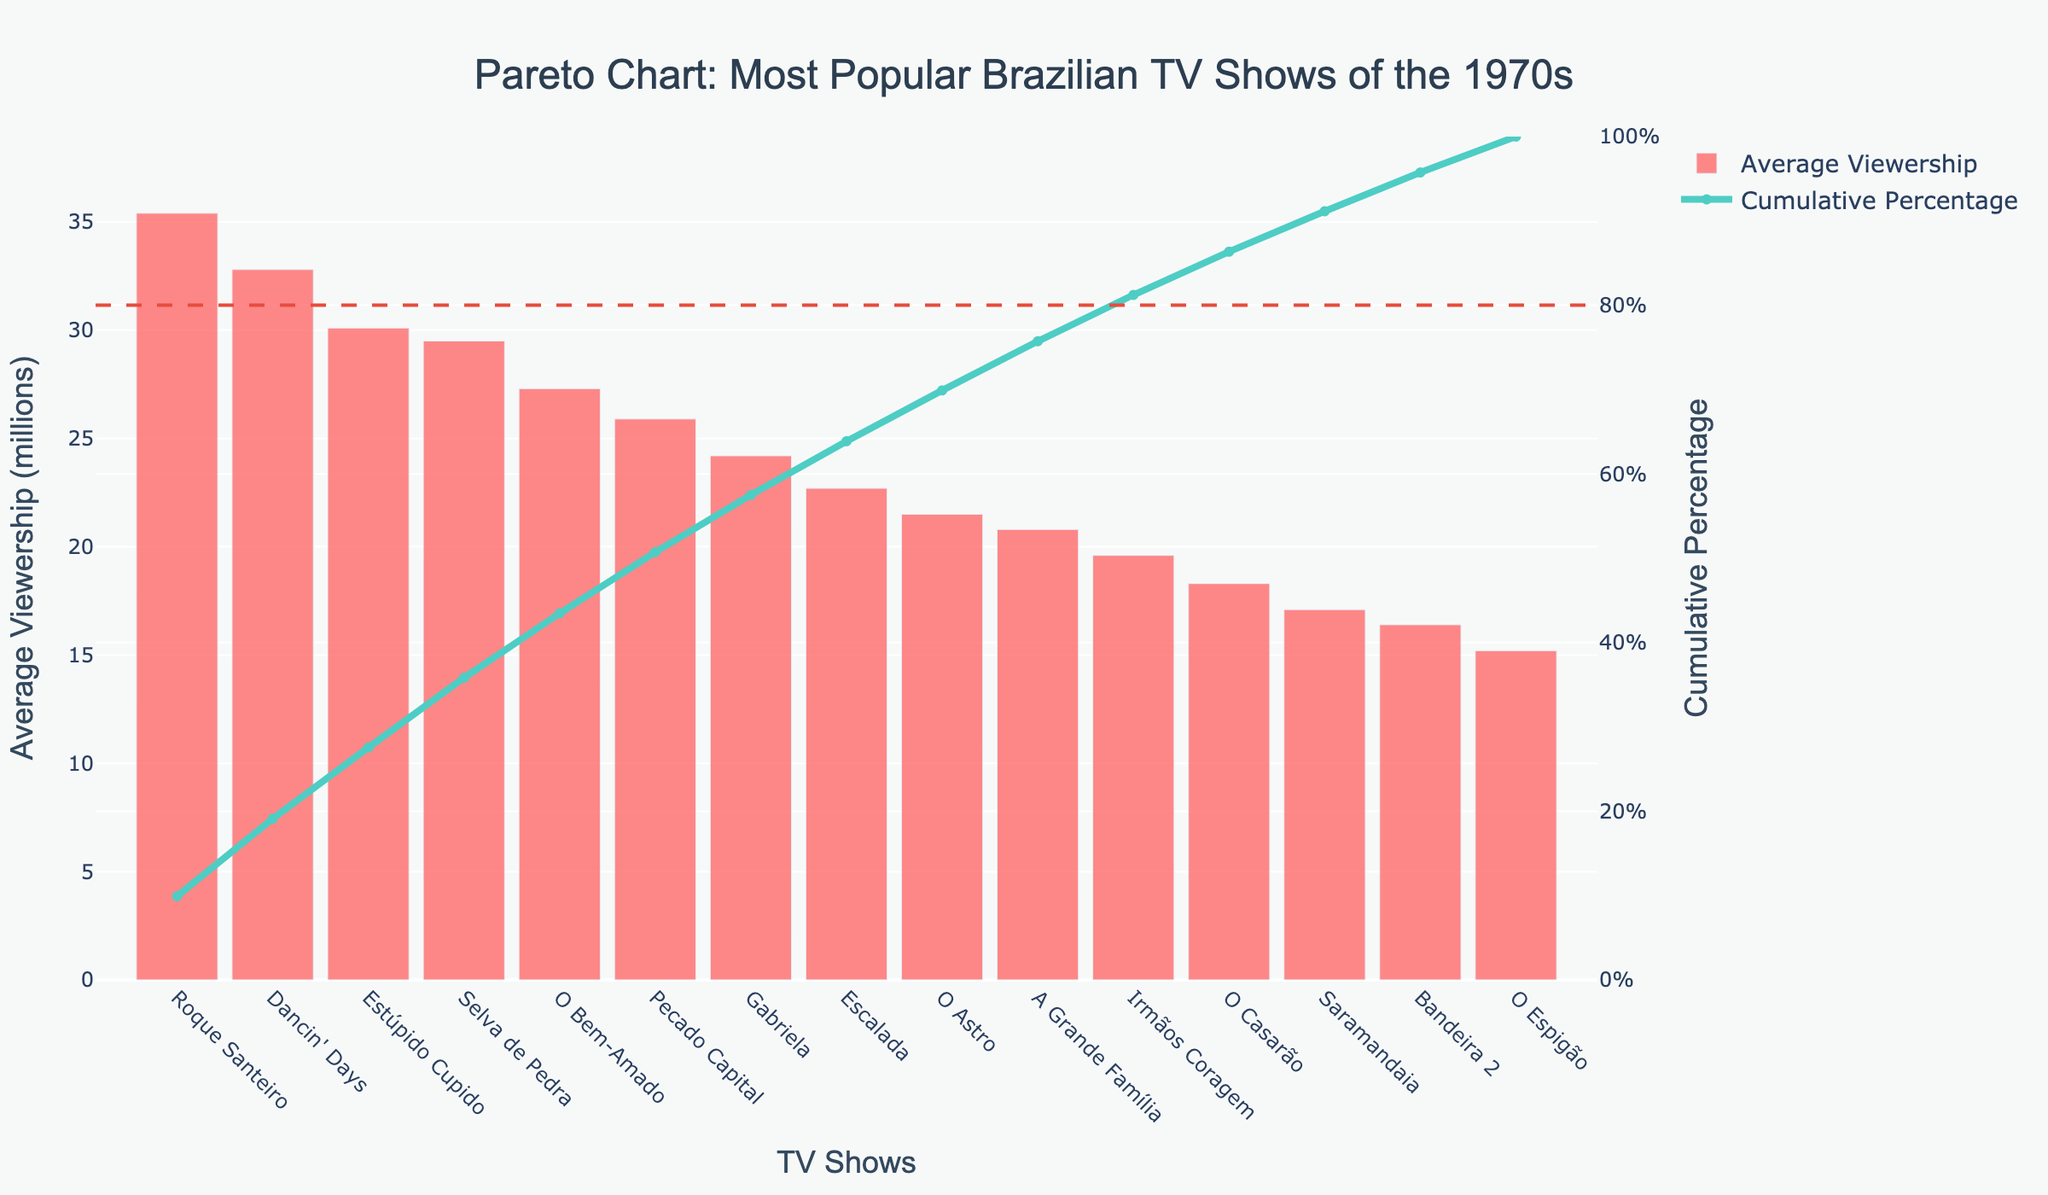What is the title of the Pareto chart? The title is prominently displayed at the top of the chart and reads "Pareto Chart: Most Popular Brazilian TV Shows of the 1970s."
Answer: Pareto Chart: Most Popular Brazilian TV Shows of the 1970s Which TV show has the highest average viewership? By looking at the bars, the tallest one represents the show with the highest average viewership. It is clear from the chart that "Roque Santeiro" has the tallest bar, indicating the highest average viewership.
Answer: Roque Santeiro How many TV shows have an average viewership above 30 million? By examining the y-axis values and aligning them with the bars, you can identify that three shows—Roque Santeiro, Dancin' Days, and Estúpido Cupido—have average viewerships above 30 million.
Answer: 3 What is the cumulative percentage for "Gabriela"? Locate "Gabriela" along the x-axis and follow the plotted line for the cumulative percentage. The value for "Gabriela" is slightly above 50%, approximately 55%.
Answer: ~55% Which show marks the point where the cumulative percentage reaches 80%? Follow the cumulative percentage line up to the 80% marker and find the corresponding show on the x-axis. It shows that the cumulative percentage reaches approximately 80% at "Gabriela."
Answer: Gabriela How much more viewership does "Roque Santeiro" have compared to "O Casarão"? Subtract the average viewership of "O Casarão" from "Roque Santeiro". Roque Santeiro has 35.4 million, and O Casarão has 18.3 million. The difference is 35.4 - 18.3 = 17.1 million.
Answer: 17.1 million What percentage of the total viewership do the top two shows account for? Sum the viewership of Roque Santeiro (35.4 million) and Dancin' Days (32.8 million) and divide by the total viewership, then multiply by 100. The total viewership is the sum of all individual viewerships, which is 356.8 million. So it is (35.4 + 32.8) / 356.8 * 100 = 19.1%.
Answer: 19.1% What color represents the cumulative percentage line on the chart? The cumulative percentage line is visually represented with a distinct color. By observing, it is clear that the line is colored in a light turquoise shade.
Answer: Light turquoise Which show has an average viewership closest to 20 million? By looking at the bars around the 20 million mark on the y-axis, you can see that "A Grande Família" closely matches this value with an average viewership of 20.8 million.
Answer: A Grande Família How many shows contribute to 50% of the total viewership? Follow the cumulative percentage curve to the 50% line and count the bars leading up to this point. The first four shows—Roque Santeiro, Dancin' Days, Estúpido Cupido, and Selva de Pedra—account for about 50% of the total viewership.
Answer: 4 shows 